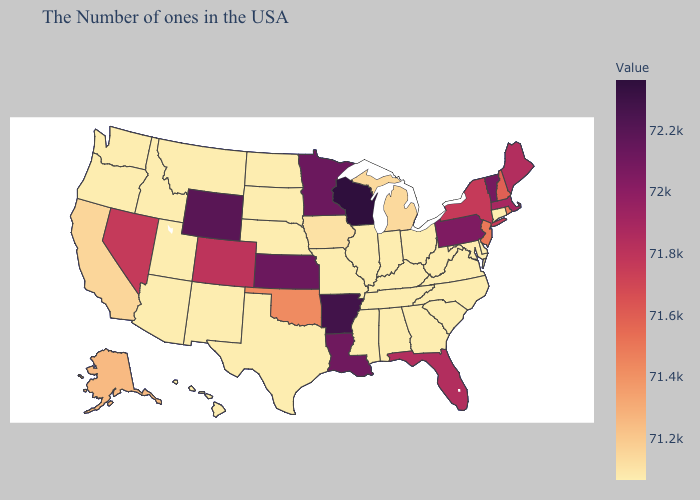Is the legend a continuous bar?
Quick response, please. Yes. Is the legend a continuous bar?
Quick response, please. Yes. Which states have the lowest value in the USA?
Keep it brief. Connecticut, Delaware, Maryland, Virginia, North Carolina, South Carolina, West Virginia, Ohio, Georgia, Kentucky, Indiana, Alabama, Tennessee, Illinois, Mississippi, Missouri, Nebraska, Texas, South Dakota, North Dakota, New Mexico, Utah, Montana, Arizona, Idaho, Washington, Oregon, Hawaii. Is the legend a continuous bar?
Write a very short answer. Yes. Among the states that border Alabama , does Florida have the highest value?
Short answer required. Yes. Does Oklahoma have the lowest value in the USA?
Keep it brief. No. 